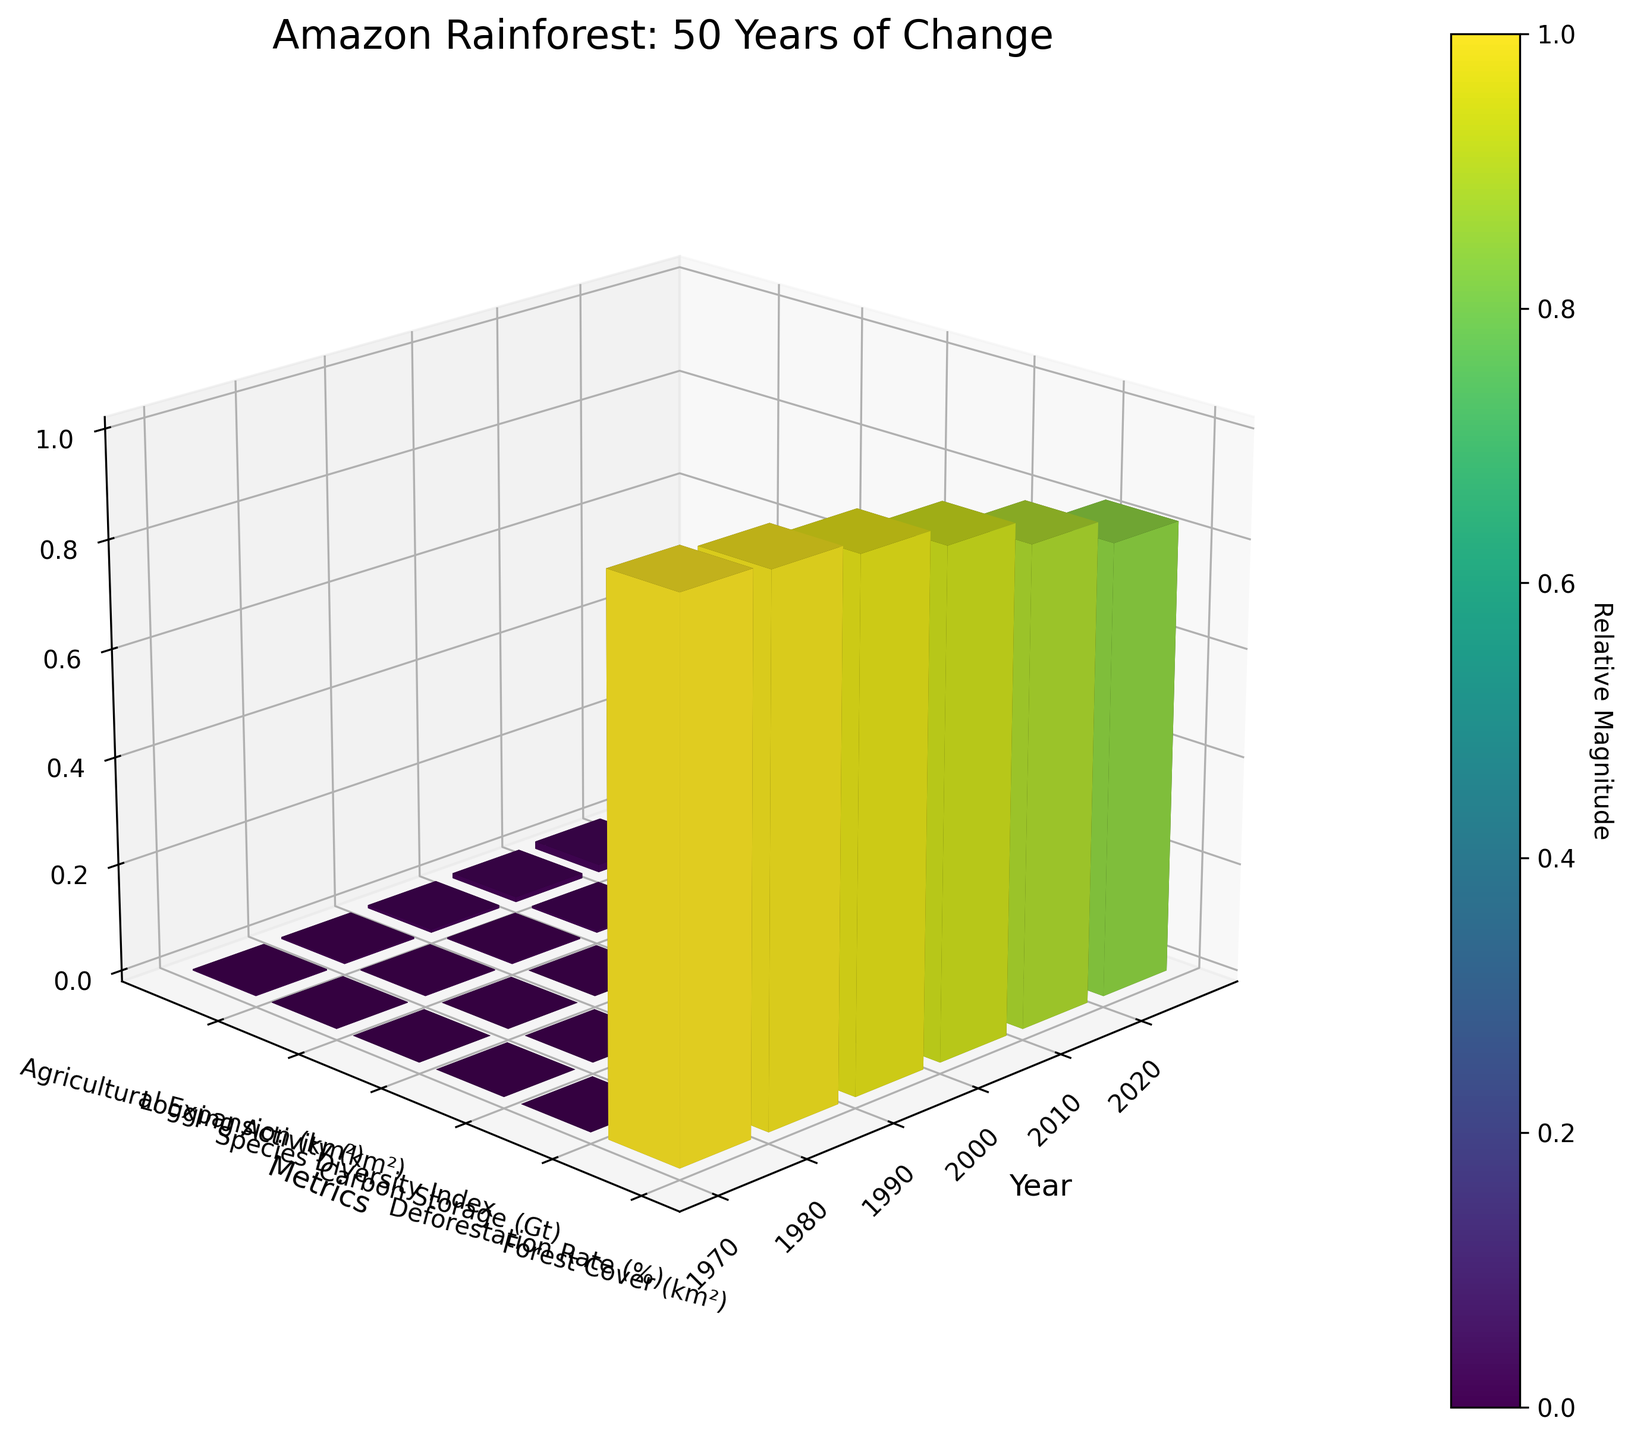How many years of data are presented in the plot? Count the number of tick labels on the x-axis, one for each year presented in the dataset. There are six years displayed (1970, 1980, 1990, 2000, 2010, 2020).
Answer: 6 What is the title of the plot? The title is displayed at the top of the figure. It reads "Amazon Rainforest: 50 Years of Change."
Answer: Amazon Rainforest: 50 Years of Change Which year had the highest logging activity? Look at the 'Logging Activity (km²)' bars across different years. The height is the tallest for the year 2020.
Answer: 2020 What metric shows the greatest decrease over time? Compare the relative height of bars for each metric from 1970 to 2020. 'Forest Cover (km²)' decreases the most significantly.
Answer: Forest Cover (km²) How does the Carbon Storage in 1990 compare to 2020? Identify the bars for 'Carbon Storage' in 1990 and 2020. The bar for 1990 is higher than the bar for 2020, indicating higher carbon storage in 1990.
Answer: Higher in 1990 What is the trend in the Species Diversity Index from 1970 to 2020? Follow the bars for the 'Species Diversity Index' from 1970 to 2020. The bars generally decrease in height, showing a downward trend.
Answer: Decreasing By how much did the Agricultural Expansion increase from 1980 to 2000? Compare the heights of the 'Agricultural Expansion (km²)' bars for 1980 and 2000. Estimate or calculate the difference from the normalized values.
Answer: 25,000 km² (from 15,000 km² to 40,000 km²) Which metric had the most constant value over the years? Look at the relative height change for each metric's bars. 'Deforestation Rate (%)' shows the smallest variation over time.
Answer: Deforestation Rate (%) What is the relative magnitude of Forest Cover (km²) in 2010 compared to 2020? Compare the height of the 'Forest Cover (km²)' bars for 2010 and 2020. Forest Cover in 2010 is higher than in 2020.
Answer: Higher in 2010 Is there a correlation between Logging Activity and Agricultural Expansion over the years? Look for synchronized behavior between 'Logging Activity (km²)' and 'Agricultural Expansion (km²)' bars over time. Both metrics increase steadily from 1970 to 2020, suggesting a positive correlation.
Answer: Yes 